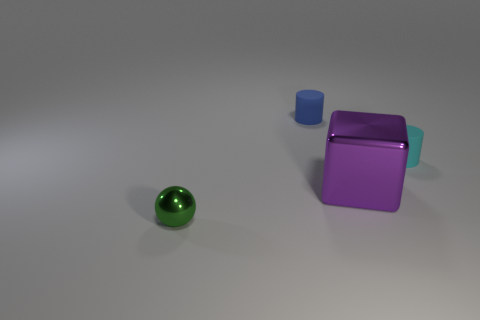Add 4 tiny blue matte cylinders. How many objects exist? 8 Subtract all blocks. How many objects are left? 3 Add 4 balls. How many balls are left? 5 Add 3 small rubber cylinders. How many small rubber cylinders exist? 5 Subtract all blue cylinders. How many cylinders are left? 1 Subtract 1 cyan cylinders. How many objects are left? 3 Subtract 1 balls. How many balls are left? 0 Subtract all blue cylinders. Subtract all blue balls. How many cylinders are left? 1 Subtract all green cylinders. How many brown cubes are left? 0 Subtract all matte cylinders. Subtract all cubes. How many objects are left? 1 